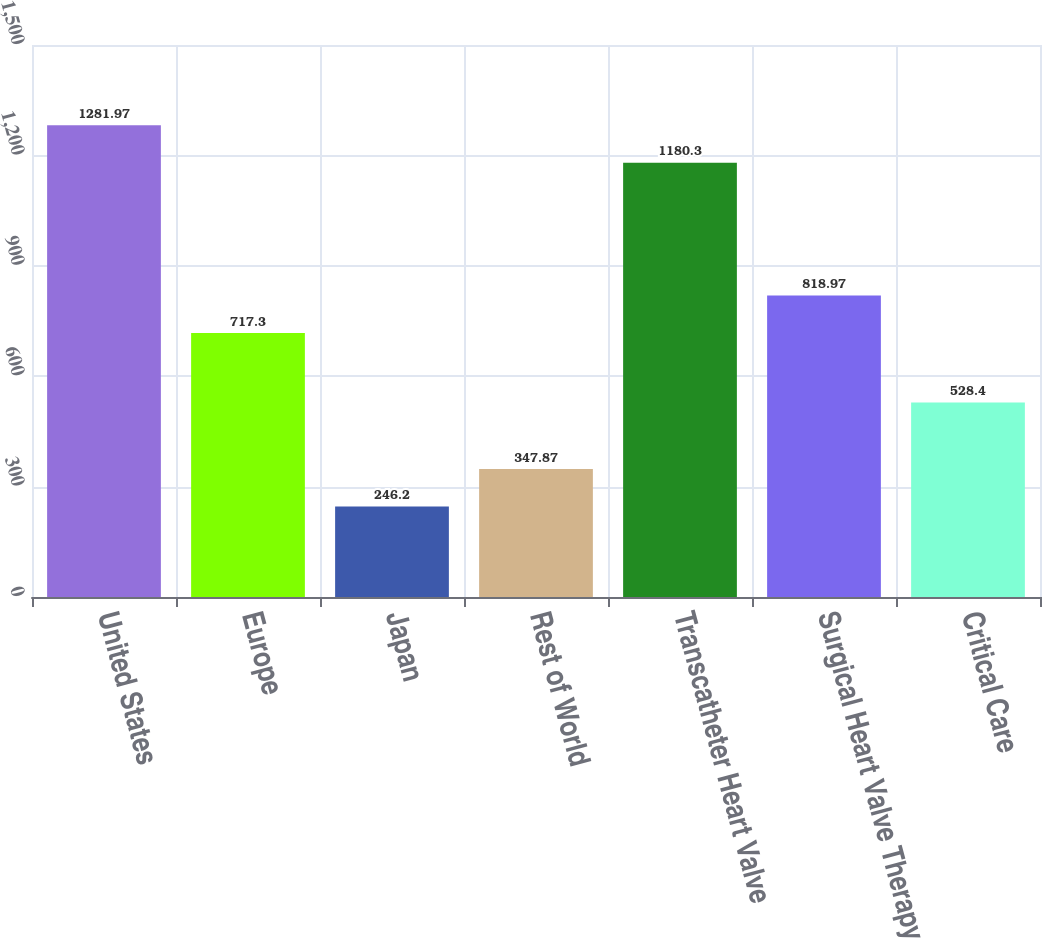<chart> <loc_0><loc_0><loc_500><loc_500><bar_chart><fcel>United States<fcel>Europe<fcel>Japan<fcel>Rest of World<fcel>Transcatheter Heart Valve<fcel>Surgical Heart Valve Therapy<fcel>Critical Care<nl><fcel>1281.97<fcel>717.3<fcel>246.2<fcel>347.87<fcel>1180.3<fcel>818.97<fcel>528.4<nl></chart> 